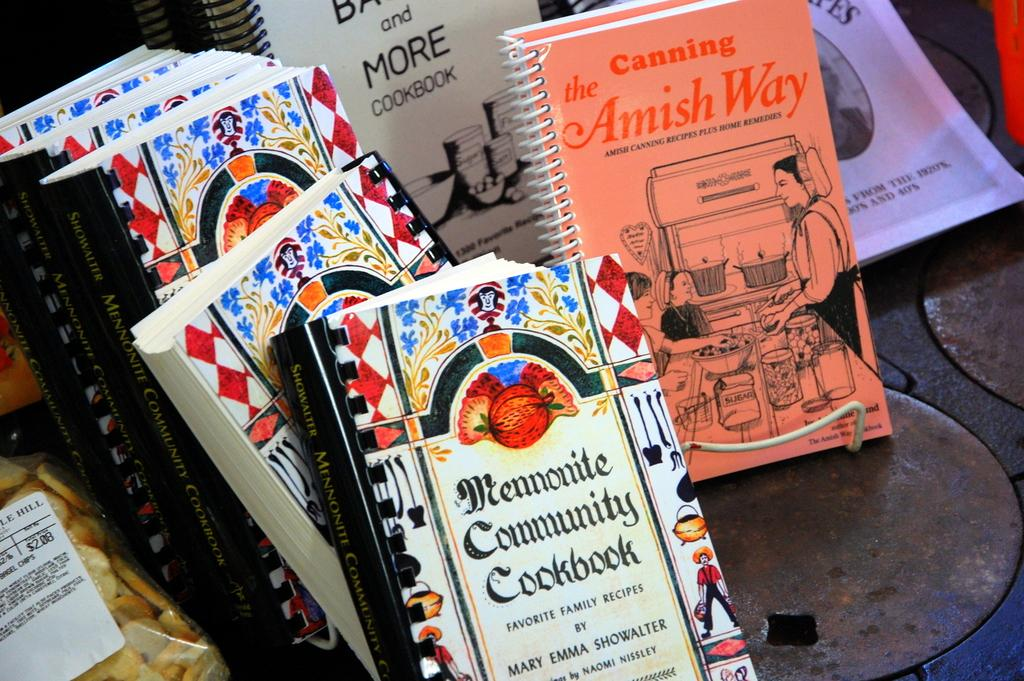<image>
Relay a brief, clear account of the picture shown. A book titled The Amish Way is among a stack of cookbooks. 